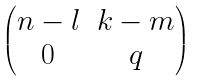Convert formula to latex. <formula><loc_0><loc_0><loc_500><loc_500>\begin{pmatrix} n - l & k - m \\ 0 & q \end{pmatrix}</formula> 